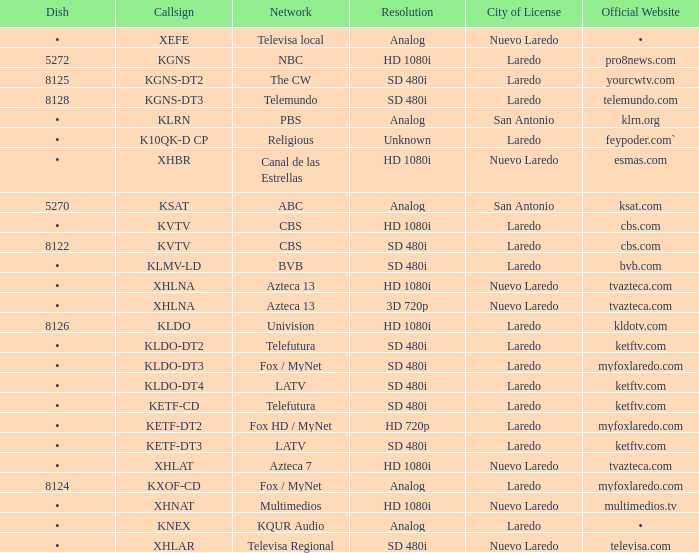Name the dish for resolution of sd 480i and network of bvb •. 